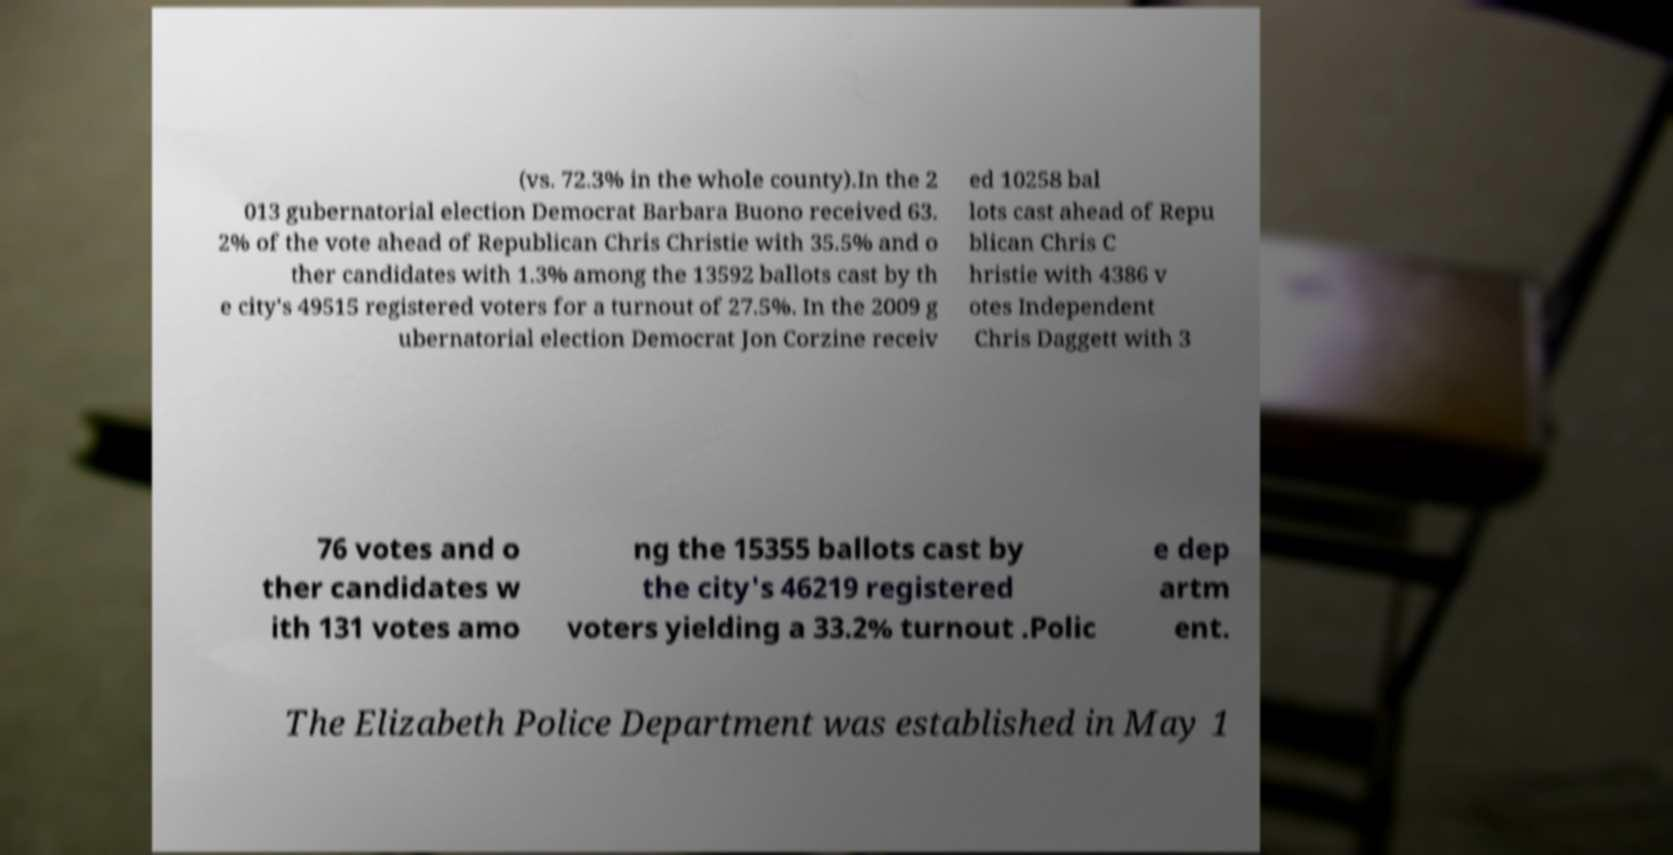What messages or text are displayed in this image? I need them in a readable, typed format. (vs. 72.3% in the whole county).In the 2 013 gubernatorial election Democrat Barbara Buono received 63. 2% of the vote ahead of Republican Chris Christie with 35.5% and o ther candidates with 1.3% among the 13592 ballots cast by th e city's 49515 registered voters for a turnout of 27.5%. In the 2009 g ubernatorial election Democrat Jon Corzine receiv ed 10258 bal lots cast ahead of Repu blican Chris C hristie with 4386 v otes Independent Chris Daggett with 3 76 votes and o ther candidates w ith 131 votes amo ng the 15355 ballots cast by the city's 46219 registered voters yielding a 33.2% turnout .Polic e dep artm ent. The Elizabeth Police Department was established in May 1 